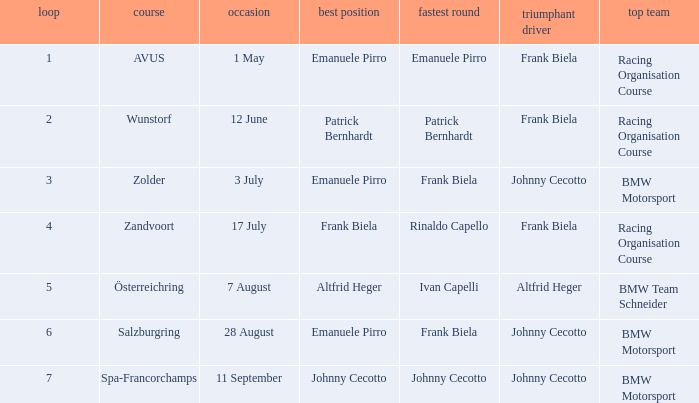Who was the winning team on the circuit Zolder? BMW Motorsport. 